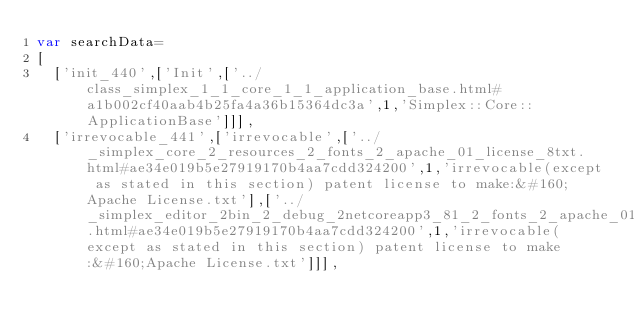Convert code to text. <code><loc_0><loc_0><loc_500><loc_500><_JavaScript_>var searchData=
[
  ['init_440',['Init',['../class_simplex_1_1_core_1_1_application_base.html#a1b002cf40aab4b25fa4a36b15364dc3a',1,'Simplex::Core::ApplicationBase']]],
  ['irrevocable_441',['irrevocable',['../_simplex_core_2_resources_2_fonts_2_apache_01_license_8txt.html#ae34e019b5e27919170b4aa7cdd324200',1,'irrevocable(except as stated in this section) patent license to make:&#160;Apache License.txt'],['../_simplex_editor_2bin_2_debug_2netcoreapp3_81_2_fonts_2_apache_01_license_8txt.html#ae34e019b5e27919170b4aa7cdd324200',1,'irrevocable(except as stated in this section) patent license to make:&#160;Apache License.txt']]],</code> 